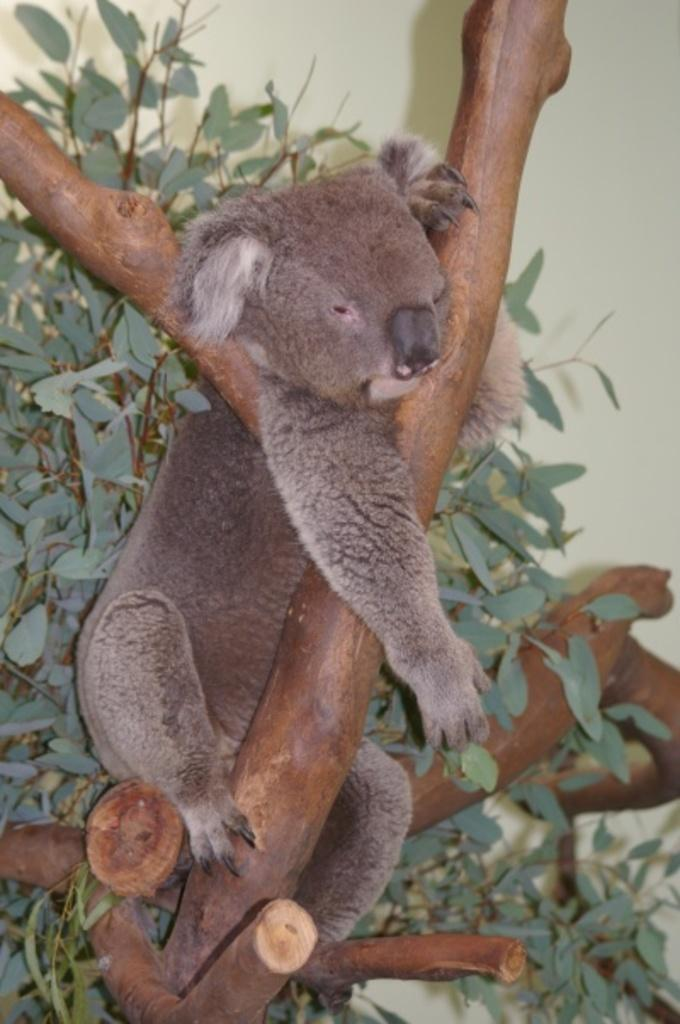What is on the tree in the image? There is an animal on the tree in the image. What can be seen in the background of the image? There is a wall visible in the background of the image. What type of exchange is taking place between the animal and the wall in the image? There is no exchange taking place between the animal and the wall in the image. The animal is on the tree, and the wall is in the background. 